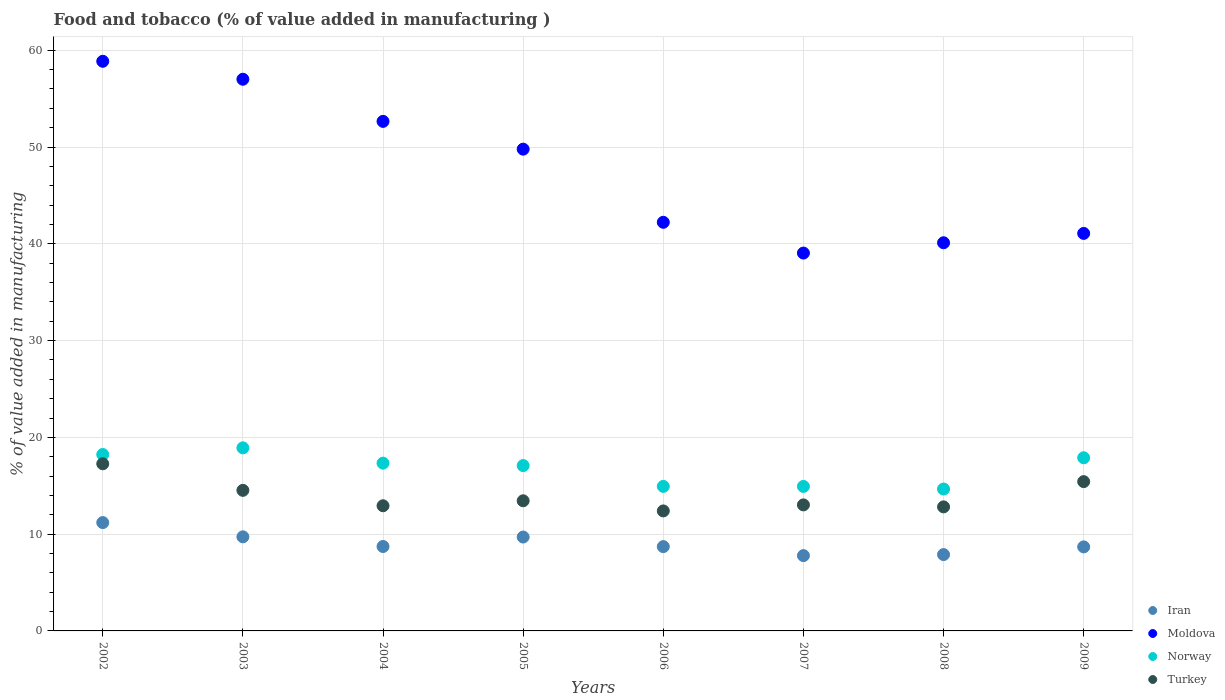How many different coloured dotlines are there?
Provide a short and direct response. 4. Is the number of dotlines equal to the number of legend labels?
Ensure brevity in your answer.  Yes. What is the value added in manufacturing food and tobacco in Iran in 2002?
Give a very brief answer. 11.19. Across all years, what is the maximum value added in manufacturing food and tobacco in Norway?
Your response must be concise. 18.92. Across all years, what is the minimum value added in manufacturing food and tobacco in Turkey?
Keep it short and to the point. 12.4. In which year was the value added in manufacturing food and tobacco in Moldova minimum?
Your answer should be compact. 2007. What is the total value added in manufacturing food and tobacco in Iran in the graph?
Offer a terse response. 72.4. What is the difference between the value added in manufacturing food and tobacco in Iran in 2006 and that in 2008?
Ensure brevity in your answer.  0.82. What is the difference between the value added in manufacturing food and tobacco in Iran in 2005 and the value added in manufacturing food and tobacco in Moldova in 2007?
Give a very brief answer. -29.34. What is the average value added in manufacturing food and tobacco in Norway per year?
Offer a very short reply. 16.75. In the year 2004, what is the difference between the value added in manufacturing food and tobacco in Turkey and value added in manufacturing food and tobacco in Norway?
Offer a very short reply. -4.4. What is the ratio of the value added in manufacturing food and tobacco in Turkey in 2006 to that in 2008?
Your answer should be very brief. 0.97. Is the difference between the value added in manufacturing food and tobacco in Turkey in 2007 and 2009 greater than the difference between the value added in manufacturing food and tobacco in Norway in 2007 and 2009?
Ensure brevity in your answer.  Yes. What is the difference between the highest and the second highest value added in manufacturing food and tobacco in Iran?
Give a very brief answer. 1.47. What is the difference between the highest and the lowest value added in manufacturing food and tobacco in Moldova?
Provide a succinct answer. 19.82. Is it the case that in every year, the sum of the value added in manufacturing food and tobacco in Norway and value added in manufacturing food and tobacco in Iran  is greater than the sum of value added in manufacturing food and tobacco in Moldova and value added in manufacturing food and tobacco in Turkey?
Ensure brevity in your answer.  No. Does the value added in manufacturing food and tobacco in Turkey monotonically increase over the years?
Ensure brevity in your answer.  No. Is the value added in manufacturing food and tobacco in Moldova strictly greater than the value added in manufacturing food and tobacco in Turkey over the years?
Offer a terse response. Yes. How many dotlines are there?
Provide a succinct answer. 4. How many years are there in the graph?
Your response must be concise. 8. Where does the legend appear in the graph?
Your response must be concise. Bottom right. How many legend labels are there?
Make the answer very short. 4. How are the legend labels stacked?
Give a very brief answer. Vertical. What is the title of the graph?
Make the answer very short. Food and tobacco (% of value added in manufacturing ). What is the label or title of the X-axis?
Your answer should be compact. Years. What is the label or title of the Y-axis?
Your answer should be very brief. % of value added in manufacturing. What is the % of value added in manufacturing of Iran in 2002?
Your answer should be very brief. 11.19. What is the % of value added in manufacturing in Moldova in 2002?
Offer a very short reply. 58.86. What is the % of value added in manufacturing of Norway in 2002?
Ensure brevity in your answer.  18.23. What is the % of value added in manufacturing of Turkey in 2002?
Provide a succinct answer. 17.27. What is the % of value added in manufacturing in Iran in 2003?
Provide a succinct answer. 9.72. What is the % of value added in manufacturing in Moldova in 2003?
Provide a short and direct response. 57. What is the % of value added in manufacturing in Norway in 2003?
Ensure brevity in your answer.  18.92. What is the % of value added in manufacturing of Turkey in 2003?
Your answer should be very brief. 14.52. What is the % of value added in manufacturing of Iran in 2004?
Offer a terse response. 8.72. What is the % of value added in manufacturing in Moldova in 2004?
Keep it short and to the point. 52.65. What is the % of value added in manufacturing of Norway in 2004?
Give a very brief answer. 17.34. What is the % of value added in manufacturing in Turkey in 2004?
Make the answer very short. 12.93. What is the % of value added in manufacturing of Iran in 2005?
Your response must be concise. 9.7. What is the % of value added in manufacturing of Moldova in 2005?
Keep it short and to the point. 49.78. What is the % of value added in manufacturing in Norway in 2005?
Keep it short and to the point. 17.08. What is the % of value added in manufacturing of Turkey in 2005?
Ensure brevity in your answer.  13.45. What is the % of value added in manufacturing in Iran in 2006?
Provide a succinct answer. 8.71. What is the % of value added in manufacturing in Moldova in 2006?
Your response must be concise. 42.22. What is the % of value added in manufacturing in Norway in 2006?
Your answer should be very brief. 14.93. What is the % of value added in manufacturing in Turkey in 2006?
Give a very brief answer. 12.4. What is the % of value added in manufacturing of Iran in 2007?
Offer a terse response. 7.78. What is the % of value added in manufacturing of Moldova in 2007?
Ensure brevity in your answer.  39.04. What is the % of value added in manufacturing in Norway in 2007?
Keep it short and to the point. 14.93. What is the % of value added in manufacturing of Turkey in 2007?
Ensure brevity in your answer.  13.02. What is the % of value added in manufacturing in Iran in 2008?
Offer a terse response. 7.89. What is the % of value added in manufacturing of Moldova in 2008?
Keep it short and to the point. 40.11. What is the % of value added in manufacturing in Norway in 2008?
Keep it short and to the point. 14.66. What is the % of value added in manufacturing in Turkey in 2008?
Your response must be concise. 12.82. What is the % of value added in manufacturing in Iran in 2009?
Give a very brief answer. 8.68. What is the % of value added in manufacturing in Moldova in 2009?
Ensure brevity in your answer.  41.07. What is the % of value added in manufacturing of Norway in 2009?
Provide a short and direct response. 17.89. What is the % of value added in manufacturing in Turkey in 2009?
Ensure brevity in your answer.  15.43. Across all years, what is the maximum % of value added in manufacturing in Iran?
Your answer should be compact. 11.19. Across all years, what is the maximum % of value added in manufacturing of Moldova?
Make the answer very short. 58.86. Across all years, what is the maximum % of value added in manufacturing of Norway?
Your response must be concise. 18.92. Across all years, what is the maximum % of value added in manufacturing of Turkey?
Offer a very short reply. 17.27. Across all years, what is the minimum % of value added in manufacturing in Iran?
Provide a succinct answer. 7.78. Across all years, what is the minimum % of value added in manufacturing in Moldova?
Give a very brief answer. 39.04. Across all years, what is the minimum % of value added in manufacturing in Norway?
Keep it short and to the point. 14.66. Across all years, what is the minimum % of value added in manufacturing of Turkey?
Your answer should be very brief. 12.4. What is the total % of value added in manufacturing in Iran in the graph?
Ensure brevity in your answer.  72.4. What is the total % of value added in manufacturing of Moldova in the graph?
Give a very brief answer. 380.73. What is the total % of value added in manufacturing of Norway in the graph?
Provide a succinct answer. 133.98. What is the total % of value added in manufacturing in Turkey in the graph?
Keep it short and to the point. 111.84. What is the difference between the % of value added in manufacturing of Iran in 2002 and that in 2003?
Offer a terse response. 1.47. What is the difference between the % of value added in manufacturing of Moldova in 2002 and that in 2003?
Offer a terse response. 1.86. What is the difference between the % of value added in manufacturing of Norway in 2002 and that in 2003?
Ensure brevity in your answer.  -0.69. What is the difference between the % of value added in manufacturing of Turkey in 2002 and that in 2003?
Offer a very short reply. 2.75. What is the difference between the % of value added in manufacturing of Iran in 2002 and that in 2004?
Ensure brevity in your answer.  2.47. What is the difference between the % of value added in manufacturing in Moldova in 2002 and that in 2004?
Your answer should be very brief. 6.21. What is the difference between the % of value added in manufacturing of Norway in 2002 and that in 2004?
Offer a terse response. 0.89. What is the difference between the % of value added in manufacturing of Turkey in 2002 and that in 2004?
Give a very brief answer. 4.34. What is the difference between the % of value added in manufacturing of Iran in 2002 and that in 2005?
Give a very brief answer. 1.49. What is the difference between the % of value added in manufacturing of Moldova in 2002 and that in 2005?
Make the answer very short. 9.08. What is the difference between the % of value added in manufacturing of Norway in 2002 and that in 2005?
Provide a short and direct response. 1.14. What is the difference between the % of value added in manufacturing of Turkey in 2002 and that in 2005?
Give a very brief answer. 3.82. What is the difference between the % of value added in manufacturing of Iran in 2002 and that in 2006?
Offer a terse response. 2.48. What is the difference between the % of value added in manufacturing of Moldova in 2002 and that in 2006?
Keep it short and to the point. 16.64. What is the difference between the % of value added in manufacturing in Norway in 2002 and that in 2006?
Your response must be concise. 3.29. What is the difference between the % of value added in manufacturing of Turkey in 2002 and that in 2006?
Offer a terse response. 4.87. What is the difference between the % of value added in manufacturing of Iran in 2002 and that in 2007?
Give a very brief answer. 3.41. What is the difference between the % of value added in manufacturing of Moldova in 2002 and that in 2007?
Ensure brevity in your answer.  19.82. What is the difference between the % of value added in manufacturing of Norway in 2002 and that in 2007?
Your response must be concise. 3.3. What is the difference between the % of value added in manufacturing in Turkey in 2002 and that in 2007?
Ensure brevity in your answer.  4.25. What is the difference between the % of value added in manufacturing of Iran in 2002 and that in 2008?
Provide a short and direct response. 3.31. What is the difference between the % of value added in manufacturing of Moldova in 2002 and that in 2008?
Keep it short and to the point. 18.75. What is the difference between the % of value added in manufacturing of Norway in 2002 and that in 2008?
Your answer should be very brief. 3.56. What is the difference between the % of value added in manufacturing of Turkey in 2002 and that in 2008?
Offer a very short reply. 4.45. What is the difference between the % of value added in manufacturing in Iran in 2002 and that in 2009?
Offer a very short reply. 2.51. What is the difference between the % of value added in manufacturing of Moldova in 2002 and that in 2009?
Ensure brevity in your answer.  17.79. What is the difference between the % of value added in manufacturing in Norway in 2002 and that in 2009?
Keep it short and to the point. 0.34. What is the difference between the % of value added in manufacturing in Turkey in 2002 and that in 2009?
Keep it short and to the point. 1.84. What is the difference between the % of value added in manufacturing in Moldova in 2003 and that in 2004?
Offer a very short reply. 4.35. What is the difference between the % of value added in manufacturing in Norway in 2003 and that in 2004?
Offer a terse response. 1.58. What is the difference between the % of value added in manufacturing of Turkey in 2003 and that in 2004?
Keep it short and to the point. 1.59. What is the difference between the % of value added in manufacturing of Iran in 2003 and that in 2005?
Provide a short and direct response. 0.02. What is the difference between the % of value added in manufacturing of Moldova in 2003 and that in 2005?
Give a very brief answer. 7.22. What is the difference between the % of value added in manufacturing in Norway in 2003 and that in 2005?
Ensure brevity in your answer.  1.83. What is the difference between the % of value added in manufacturing in Turkey in 2003 and that in 2005?
Provide a succinct answer. 1.08. What is the difference between the % of value added in manufacturing in Iran in 2003 and that in 2006?
Your answer should be compact. 1.01. What is the difference between the % of value added in manufacturing of Moldova in 2003 and that in 2006?
Your response must be concise. 14.78. What is the difference between the % of value added in manufacturing in Norway in 2003 and that in 2006?
Your answer should be very brief. 3.98. What is the difference between the % of value added in manufacturing in Turkey in 2003 and that in 2006?
Your answer should be very brief. 2.13. What is the difference between the % of value added in manufacturing of Iran in 2003 and that in 2007?
Offer a very short reply. 1.94. What is the difference between the % of value added in manufacturing of Moldova in 2003 and that in 2007?
Offer a terse response. 17.96. What is the difference between the % of value added in manufacturing in Norway in 2003 and that in 2007?
Keep it short and to the point. 3.99. What is the difference between the % of value added in manufacturing in Turkey in 2003 and that in 2007?
Your response must be concise. 1.5. What is the difference between the % of value added in manufacturing in Iran in 2003 and that in 2008?
Your answer should be very brief. 1.84. What is the difference between the % of value added in manufacturing of Moldova in 2003 and that in 2008?
Give a very brief answer. 16.9. What is the difference between the % of value added in manufacturing of Norway in 2003 and that in 2008?
Give a very brief answer. 4.25. What is the difference between the % of value added in manufacturing of Turkey in 2003 and that in 2008?
Your answer should be very brief. 1.71. What is the difference between the % of value added in manufacturing of Iran in 2003 and that in 2009?
Provide a succinct answer. 1.04. What is the difference between the % of value added in manufacturing in Moldova in 2003 and that in 2009?
Give a very brief answer. 15.93. What is the difference between the % of value added in manufacturing in Norway in 2003 and that in 2009?
Offer a very short reply. 1.03. What is the difference between the % of value added in manufacturing of Turkey in 2003 and that in 2009?
Your answer should be compact. -0.9. What is the difference between the % of value added in manufacturing in Iran in 2004 and that in 2005?
Offer a very short reply. -0.98. What is the difference between the % of value added in manufacturing of Moldova in 2004 and that in 2005?
Provide a short and direct response. 2.87. What is the difference between the % of value added in manufacturing of Norway in 2004 and that in 2005?
Give a very brief answer. 0.25. What is the difference between the % of value added in manufacturing in Turkey in 2004 and that in 2005?
Offer a very short reply. -0.51. What is the difference between the % of value added in manufacturing of Iran in 2004 and that in 2006?
Offer a terse response. 0.01. What is the difference between the % of value added in manufacturing of Moldova in 2004 and that in 2006?
Provide a short and direct response. 10.43. What is the difference between the % of value added in manufacturing in Norway in 2004 and that in 2006?
Keep it short and to the point. 2.4. What is the difference between the % of value added in manufacturing in Turkey in 2004 and that in 2006?
Give a very brief answer. 0.53. What is the difference between the % of value added in manufacturing of Iran in 2004 and that in 2007?
Your answer should be compact. 0.94. What is the difference between the % of value added in manufacturing of Moldova in 2004 and that in 2007?
Make the answer very short. 13.61. What is the difference between the % of value added in manufacturing in Norway in 2004 and that in 2007?
Ensure brevity in your answer.  2.41. What is the difference between the % of value added in manufacturing of Turkey in 2004 and that in 2007?
Give a very brief answer. -0.09. What is the difference between the % of value added in manufacturing of Iran in 2004 and that in 2008?
Offer a terse response. 0.84. What is the difference between the % of value added in manufacturing in Moldova in 2004 and that in 2008?
Keep it short and to the point. 12.54. What is the difference between the % of value added in manufacturing in Norway in 2004 and that in 2008?
Provide a succinct answer. 2.67. What is the difference between the % of value added in manufacturing of Turkey in 2004 and that in 2008?
Offer a very short reply. 0.12. What is the difference between the % of value added in manufacturing of Iran in 2004 and that in 2009?
Make the answer very short. 0.04. What is the difference between the % of value added in manufacturing in Moldova in 2004 and that in 2009?
Keep it short and to the point. 11.58. What is the difference between the % of value added in manufacturing in Norway in 2004 and that in 2009?
Ensure brevity in your answer.  -0.56. What is the difference between the % of value added in manufacturing in Turkey in 2004 and that in 2009?
Your answer should be compact. -2.49. What is the difference between the % of value added in manufacturing of Iran in 2005 and that in 2006?
Provide a short and direct response. 0.99. What is the difference between the % of value added in manufacturing of Moldova in 2005 and that in 2006?
Your response must be concise. 7.56. What is the difference between the % of value added in manufacturing in Norway in 2005 and that in 2006?
Give a very brief answer. 2.15. What is the difference between the % of value added in manufacturing in Turkey in 2005 and that in 2006?
Your answer should be very brief. 1.05. What is the difference between the % of value added in manufacturing in Iran in 2005 and that in 2007?
Your answer should be very brief. 1.92. What is the difference between the % of value added in manufacturing of Moldova in 2005 and that in 2007?
Your answer should be very brief. 10.74. What is the difference between the % of value added in manufacturing in Norway in 2005 and that in 2007?
Offer a terse response. 2.16. What is the difference between the % of value added in manufacturing of Turkey in 2005 and that in 2007?
Offer a terse response. 0.42. What is the difference between the % of value added in manufacturing in Iran in 2005 and that in 2008?
Offer a terse response. 1.81. What is the difference between the % of value added in manufacturing in Moldova in 2005 and that in 2008?
Your response must be concise. 9.67. What is the difference between the % of value added in manufacturing in Norway in 2005 and that in 2008?
Keep it short and to the point. 2.42. What is the difference between the % of value added in manufacturing in Turkey in 2005 and that in 2008?
Offer a very short reply. 0.63. What is the difference between the % of value added in manufacturing of Iran in 2005 and that in 2009?
Keep it short and to the point. 1.02. What is the difference between the % of value added in manufacturing of Moldova in 2005 and that in 2009?
Your answer should be very brief. 8.71. What is the difference between the % of value added in manufacturing of Norway in 2005 and that in 2009?
Offer a very short reply. -0.81. What is the difference between the % of value added in manufacturing of Turkey in 2005 and that in 2009?
Offer a very short reply. -1.98. What is the difference between the % of value added in manufacturing of Iran in 2006 and that in 2007?
Offer a terse response. 0.93. What is the difference between the % of value added in manufacturing in Moldova in 2006 and that in 2007?
Your response must be concise. 3.18. What is the difference between the % of value added in manufacturing in Norway in 2006 and that in 2007?
Ensure brevity in your answer.  0.01. What is the difference between the % of value added in manufacturing in Turkey in 2006 and that in 2007?
Ensure brevity in your answer.  -0.62. What is the difference between the % of value added in manufacturing in Iran in 2006 and that in 2008?
Provide a short and direct response. 0.82. What is the difference between the % of value added in manufacturing in Moldova in 2006 and that in 2008?
Ensure brevity in your answer.  2.11. What is the difference between the % of value added in manufacturing of Norway in 2006 and that in 2008?
Your answer should be very brief. 0.27. What is the difference between the % of value added in manufacturing of Turkey in 2006 and that in 2008?
Make the answer very short. -0.42. What is the difference between the % of value added in manufacturing in Iran in 2006 and that in 2009?
Provide a short and direct response. 0.03. What is the difference between the % of value added in manufacturing of Moldova in 2006 and that in 2009?
Give a very brief answer. 1.15. What is the difference between the % of value added in manufacturing of Norway in 2006 and that in 2009?
Offer a terse response. -2.96. What is the difference between the % of value added in manufacturing in Turkey in 2006 and that in 2009?
Your answer should be very brief. -3.03. What is the difference between the % of value added in manufacturing of Iran in 2007 and that in 2008?
Keep it short and to the point. -0.11. What is the difference between the % of value added in manufacturing of Moldova in 2007 and that in 2008?
Offer a very short reply. -1.06. What is the difference between the % of value added in manufacturing in Norway in 2007 and that in 2008?
Offer a terse response. 0.27. What is the difference between the % of value added in manufacturing in Turkey in 2007 and that in 2008?
Your answer should be very brief. 0.21. What is the difference between the % of value added in manufacturing of Iran in 2007 and that in 2009?
Offer a very short reply. -0.9. What is the difference between the % of value added in manufacturing of Moldova in 2007 and that in 2009?
Your response must be concise. -2.03. What is the difference between the % of value added in manufacturing in Norway in 2007 and that in 2009?
Offer a very short reply. -2.96. What is the difference between the % of value added in manufacturing in Turkey in 2007 and that in 2009?
Your response must be concise. -2.4. What is the difference between the % of value added in manufacturing of Iran in 2008 and that in 2009?
Make the answer very short. -0.8. What is the difference between the % of value added in manufacturing in Moldova in 2008 and that in 2009?
Your answer should be very brief. -0.97. What is the difference between the % of value added in manufacturing in Norway in 2008 and that in 2009?
Offer a terse response. -3.23. What is the difference between the % of value added in manufacturing of Turkey in 2008 and that in 2009?
Offer a terse response. -2.61. What is the difference between the % of value added in manufacturing in Iran in 2002 and the % of value added in manufacturing in Moldova in 2003?
Give a very brief answer. -45.81. What is the difference between the % of value added in manufacturing in Iran in 2002 and the % of value added in manufacturing in Norway in 2003?
Ensure brevity in your answer.  -7.72. What is the difference between the % of value added in manufacturing in Iran in 2002 and the % of value added in manufacturing in Turkey in 2003?
Your answer should be compact. -3.33. What is the difference between the % of value added in manufacturing of Moldova in 2002 and the % of value added in manufacturing of Norway in 2003?
Make the answer very short. 39.94. What is the difference between the % of value added in manufacturing of Moldova in 2002 and the % of value added in manufacturing of Turkey in 2003?
Offer a very short reply. 44.33. What is the difference between the % of value added in manufacturing in Norway in 2002 and the % of value added in manufacturing in Turkey in 2003?
Provide a succinct answer. 3.7. What is the difference between the % of value added in manufacturing of Iran in 2002 and the % of value added in manufacturing of Moldova in 2004?
Give a very brief answer. -41.46. What is the difference between the % of value added in manufacturing in Iran in 2002 and the % of value added in manufacturing in Norway in 2004?
Keep it short and to the point. -6.14. What is the difference between the % of value added in manufacturing of Iran in 2002 and the % of value added in manufacturing of Turkey in 2004?
Keep it short and to the point. -1.74. What is the difference between the % of value added in manufacturing in Moldova in 2002 and the % of value added in manufacturing in Norway in 2004?
Your response must be concise. 41.52. What is the difference between the % of value added in manufacturing in Moldova in 2002 and the % of value added in manufacturing in Turkey in 2004?
Offer a very short reply. 45.93. What is the difference between the % of value added in manufacturing in Norway in 2002 and the % of value added in manufacturing in Turkey in 2004?
Give a very brief answer. 5.3. What is the difference between the % of value added in manufacturing in Iran in 2002 and the % of value added in manufacturing in Moldova in 2005?
Make the answer very short. -38.59. What is the difference between the % of value added in manufacturing of Iran in 2002 and the % of value added in manufacturing of Norway in 2005?
Offer a very short reply. -5.89. What is the difference between the % of value added in manufacturing of Iran in 2002 and the % of value added in manufacturing of Turkey in 2005?
Give a very brief answer. -2.25. What is the difference between the % of value added in manufacturing of Moldova in 2002 and the % of value added in manufacturing of Norway in 2005?
Your answer should be compact. 41.77. What is the difference between the % of value added in manufacturing in Moldova in 2002 and the % of value added in manufacturing in Turkey in 2005?
Provide a short and direct response. 45.41. What is the difference between the % of value added in manufacturing of Norway in 2002 and the % of value added in manufacturing of Turkey in 2005?
Your response must be concise. 4.78. What is the difference between the % of value added in manufacturing in Iran in 2002 and the % of value added in manufacturing in Moldova in 2006?
Offer a very short reply. -31.03. What is the difference between the % of value added in manufacturing in Iran in 2002 and the % of value added in manufacturing in Norway in 2006?
Offer a very short reply. -3.74. What is the difference between the % of value added in manufacturing of Iran in 2002 and the % of value added in manufacturing of Turkey in 2006?
Ensure brevity in your answer.  -1.2. What is the difference between the % of value added in manufacturing in Moldova in 2002 and the % of value added in manufacturing in Norway in 2006?
Your response must be concise. 43.92. What is the difference between the % of value added in manufacturing of Moldova in 2002 and the % of value added in manufacturing of Turkey in 2006?
Keep it short and to the point. 46.46. What is the difference between the % of value added in manufacturing in Norway in 2002 and the % of value added in manufacturing in Turkey in 2006?
Your answer should be very brief. 5.83. What is the difference between the % of value added in manufacturing in Iran in 2002 and the % of value added in manufacturing in Moldova in 2007?
Make the answer very short. -27.85. What is the difference between the % of value added in manufacturing of Iran in 2002 and the % of value added in manufacturing of Norway in 2007?
Your response must be concise. -3.74. What is the difference between the % of value added in manufacturing in Iran in 2002 and the % of value added in manufacturing in Turkey in 2007?
Provide a short and direct response. -1.83. What is the difference between the % of value added in manufacturing in Moldova in 2002 and the % of value added in manufacturing in Norway in 2007?
Offer a very short reply. 43.93. What is the difference between the % of value added in manufacturing of Moldova in 2002 and the % of value added in manufacturing of Turkey in 2007?
Give a very brief answer. 45.84. What is the difference between the % of value added in manufacturing in Norway in 2002 and the % of value added in manufacturing in Turkey in 2007?
Offer a terse response. 5.21. What is the difference between the % of value added in manufacturing in Iran in 2002 and the % of value added in manufacturing in Moldova in 2008?
Your answer should be very brief. -28.91. What is the difference between the % of value added in manufacturing in Iran in 2002 and the % of value added in manufacturing in Norway in 2008?
Your answer should be compact. -3.47. What is the difference between the % of value added in manufacturing of Iran in 2002 and the % of value added in manufacturing of Turkey in 2008?
Offer a terse response. -1.62. What is the difference between the % of value added in manufacturing of Moldova in 2002 and the % of value added in manufacturing of Norway in 2008?
Give a very brief answer. 44.2. What is the difference between the % of value added in manufacturing in Moldova in 2002 and the % of value added in manufacturing in Turkey in 2008?
Provide a succinct answer. 46.04. What is the difference between the % of value added in manufacturing of Norway in 2002 and the % of value added in manufacturing of Turkey in 2008?
Provide a succinct answer. 5.41. What is the difference between the % of value added in manufacturing in Iran in 2002 and the % of value added in manufacturing in Moldova in 2009?
Your response must be concise. -29.88. What is the difference between the % of value added in manufacturing in Iran in 2002 and the % of value added in manufacturing in Norway in 2009?
Your response must be concise. -6.7. What is the difference between the % of value added in manufacturing of Iran in 2002 and the % of value added in manufacturing of Turkey in 2009?
Provide a succinct answer. -4.23. What is the difference between the % of value added in manufacturing of Moldova in 2002 and the % of value added in manufacturing of Norway in 2009?
Offer a very short reply. 40.97. What is the difference between the % of value added in manufacturing in Moldova in 2002 and the % of value added in manufacturing in Turkey in 2009?
Ensure brevity in your answer.  43.43. What is the difference between the % of value added in manufacturing of Norway in 2002 and the % of value added in manufacturing of Turkey in 2009?
Your response must be concise. 2.8. What is the difference between the % of value added in manufacturing of Iran in 2003 and the % of value added in manufacturing of Moldova in 2004?
Offer a very short reply. -42.93. What is the difference between the % of value added in manufacturing in Iran in 2003 and the % of value added in manufacturing in Norway in 2004?
Your response must be concise. -7.61. What is the difference between the % of value added in manufacturing of Iran in 2003 and the % of value added in manufacturing of Turkey in 2004?
Provide a succinct answer. -3.21. What is the difference between the % of value added in manufacturing in Moldova in 2003 and the % of value added in manufacturing in Norway in 2004?
Provide a succinct answer. 39.67. What is the difference between the % of value added in manufacturing of Moldova in 2003 and the % of value added in manufacturing of Turkey in 2004?
Your answer should be very brief. 44.07. What is the difference between the % of value added in manufacturing of Norway in 2003 and the % of value added in manufacturing of Turkey in 2004?
Your response must be concise. 5.99. What is the difference between the % of value added in manufacturing in Iran in 2003 and the % of value added in manufacturing in Moldova in 2005?
Provide a short and direct response. -40.06. What is the difference between the % of value added in manufacturing in Iran in 2003 and the % of value added in manufacturing in Norway in 2005?
Your answer should be compact. -7.36. What is the difference between the % of value added in manufacturing of Iran in 2003 and the % of value added in manufacturing of Turkey in 2005?
Provide a succinct answer. -3.72. What is the difference between the % of value added in manufacturing in Moldova in 2003 and the % of value added in manufacturing in Norway in 2005?
Keep it short and to the point. 39.92. What is the difference between the % of value added in manufacturing in Moldova in 2003 and the % of value added in manufacturing in Turkey in 2005?
Provide a short and direct response. 43.56. What is the difference between the % of value added in manufacturing of Norway in 2003 and the % of value added in manufacturing of Turkey in 2005?
Offer a terse response. 5.47. What is the difference between the % of value added in manufacturing of Iran in 2003 and the % of value added in manufacturing of Moldova in 2006?
Your answer should be very brief. -32.5. What is the difference between the % of value added in manufacturing in Iran in 2003 and the % of value added in manufacturing in Norway in 2006?
Provide a short and direct response. -5.21. What is the difference between the % of value added in manufacturing of Iran in 2003 and the % of value added in manufacturing of Turkey in 2006?
Offer a very short reply. -2.68. What is the difference between the % of value added in manufacturing of Moldova in 2003 and the % of value added in manufacturing of Norway in 2006?
Make the answer very short. 42.07. What is the difference between the % of value added in manufacturing of Moldova in 2003 and the % of value added in manufacturing of Turkey in 2006?
Give a very brief answer. 44.6. What is the difference between the % of value added in manufacturing in Norway in 2003 and the % of value added in manufacturing in Turkey in 2006?
Keep it short and to the point. 6.52. What is the difference between the % of value added in manufacturing in Iran in 2003 and the % of value added in manufacturing in Moldova in 2007?
Provide a succinct answer. -29.32. What is the difference between the % of value added in manufacturing of Iran in 2003 and the % of value added in manufacturing of Norway in 2007?
Your answer should be very brief. -5.21. What is the difference between the % of value added in manufacturing of Iran in 2003 and the % of value added in manufacturing of Turkey in 2007?
Keep it short and to the point. -3.3. What is the difference between the % of value added in manufacturing in Moldova in 2003 and the % of value added in manufacturing in Norway in 2007?
Ensure brevity in your answer.  42.07. What is the difference between the % of value added in manufacturing of Moldova in 2003 and the % of value added in manufacturing of Turkey in 2007?
Provide a short and direct response. 43.98. What is the difference between the % of value added in manufacturing in Norway in 2003 and the % of value added in manufacturing in Turkey in 2007?
Your answer should be very brief. 5.89. What is the difference between the % of value added in manufacturing in Iran in 2003 and the % of value added in manufacturing in Moldova in 2008?
Give a very brief answer. -30.38. What is the difference between the % of value added in manufacturing in Iran in 2003 and the % of value added in manufacturing in Norway in 2008?
Make the answer very short. -4.94. What is the difference between the % of value added in manufacturing of Iran in 2003 and the % of value added in manufacturing of Turkey in 2008?
Offer a very short reply. -3.09. What is the difference between the % of value added in manufacturing in Moldova in 2003 and the % of value added in manufacturing in Norway in 2008?
Your answer should be very brief. 42.34. What is the difference between the % of value added in manufacturing of Moldova in 2003 and the % of value added in manufacturing of Turkey in 2008?
Keep it short and to the point. 44.19. What is the difference between the % of value added in manufacturing of Norway in 2003 and the % of value added in manufacturing of Turkey in 2008?
Your answer should be compact. 6.1. What is the difference between the % of value added in manufacturing in Iran in 2003 and the % of value added in manufacturing in Moldova in 2009?
Provide a succinct answer. -31.35. What is the difference between the % of value added in manufacturing of Iran in 2003 and the % of value added in manufacturing of Norway in 2009?
Your answer should be very brief. -8.17. What is the difference between the % of value added in manufacturing of Iran in 2003 and the % of value added in manufacturing of Turkey in 2009?
Provide a short and direct response. -5.7. What is the difference between the % of value added in manufacturing in Moldova in 2003 and the % of value added in manufacturing in Norway in 2009?
Ensure brevity in your answer.  39.11. What is the difference between the % of value added in manufacturing in Moldova in 2003 and the % of value added in manufacturing in Turkey in 2009?
Ensure brevity in your answer.  41.58. What is the difference between the % of value added in manufacturing in Norway in 2003 and the % of value added in manufacturing in Turkey in 2009?
Keep it short and to the point. 3.49. What is the difference between the % of value added in manufacturing of Iran in 2004 and the % of value added in manufacturing of Moldova in 2005?
Offer a very short reply. -41.06. What is the difference between the % of value added in manufacturing in Iran in 2004 and the % of value added in manufacturing in Norway in 2005?
Your answer should be very brief. -8.36. What is the difference between the % of value added in manufacturing of Iran in 2004 and the % of value added in manufacturing of Turkey in 2005?
Your answer should be compact. -4.72. What is the difference between the % of value added in manufacturing of Moldova in 2004 and the % of value added in manufacturing of Norway in 2005?
Provide a short and direct response. 35.56. What is the difference between the % of value added in manufacturing of Moldova in 2004 and the % of value added in manufacturing of Turkey in 2005?
Offer a terse response. 39.2. What is the difference between the % of value added in manufacturing of Norway in 2004 and the % of value added in manufacturing of Turkey in 2005?
Keep it short and to the point. 3.89. What is the difference between the % of value added in manufacturing of Iran in 2004 and the % of value added in manufacturing of Moldova in 2006?
Keep it short and to the point. -33.5. What is the difference between the % of value added in manufacturing of Iran in 2004 and the % of value added in manufacturing of Norway in 2006?
Give a very brief answer. -6.21. What is the difference between the % of value added in manufacturing in Iran in 2004 and the % of value added in manufacturing in Turkey in 2006?
Keep it short and to the point. -3.68. What is the difference between the % of value added in manufacturing in Moldova in 2004 and the % of value added in manufacturing in Norway in 2006?
Ensure brevity in your answer.  37.72. What is the difference between the % of value added in manufacturing of Moldova in 2004 and the % of value added in manufacturing of Turkey in 2006?
Your answer should be compact. 40.25. What is the difference between the % of value added in manufacturing in Norway in 2004 and the % of value added in manufacturing in Turkey in 2006?
Provide a succinct answer. 4.94. What is the difference between the % of value added in manufacturing in Iran in 2004 and the % of value added in manufacturing in Moldova in 2007?
Your answer should be very brief. -30.32. What is the difference between the % of value added in manufacturing in Iran in 2004 and the % of value added in manufacturing in Norway in 2007?
Your answer should be compact. -6.21. What is the difference between the % of value added in manufacturing in Iran in 2004 and the % of value added in manufacturing in Turkey in 2007?
Your response must be concise. -4.3. What is the difference between the % of value added in manufacturing of Moldova in 2004 and the % of value added in manufacturing of Norway in 2007?
Provide a short and direct response. 37.72. What is the difference between the % of value added in manufacturing of Moldova in 2004 and the % of value added in manufacturing of Turkey in 2007?
Make the answer very short. 39.63. What is the difference between the % of value added in manufacturing of Norway in 2004 and the % of value added in manufacturing of Turkey in 2007?
Provide a succinct answer. 4.31. What is the difference between the % of value added in manufacturing of Iran in 2004 and the % of value added in manufacturing of Moldova in 2008?
Ensure brevity in your answer.  -31.38. What is the difference between the % of value added in manufacturing in Iran in 2004 and the % of value added in manufacturing in Norway in 2008?
Give a very brief answer. -5.94. What is the difference between the % of value added in manufacturing in Iran in 2004 and the % of value added in manufacturing in Turkey in 2008?
Offer a terse response. -4.09. What is the difference between the % of value added in manufacturing in Moldova in 2004 and the % of value added in manufacturing in Norway in 2008?
Your answer should be very brief. 37.99. What is the difference between the % of value added in manufacturing in Moldova in 2004 and the % of value added in manufacturing in Turkey in 2008?
Offer a terse response. 39.83. What is the difference between the % of value added in manufacturing of Norway in 2004 and the % of value added in manufacturing of Turkey in 2008?
Provide a succinct answer. 4.52. What is the difference between the % of value added in manufacturing of Iran in 2004 and the % of value added in manufacturing of Moldova in 2009?
Your answer should be compact. -32.35. What is the difference between the % of value added in manufacturing of Iran in 2004 and the % of value added in manufacturing of Norway in 2009?
Make the answer very short. -9.17. What is the difference between the % of value added in manufacturing in Iran in 2004 and the % of value added in manufacturing in Turkey in 2009?
Your response must be concise. -6.7. What is the difference between the % of value added in manufacturing of Moldova in 2004 and the % of value added in manufacturing of Norway in 2009?
Make the answer very short. 34.76. What is the difference between the % of value added in manufacturing in Moldova in 2004 and the % of value added in manufacturing in Turkey in 2009?
Your response must be concise. 37.22. What is the difference between the % of value added in manufacturing in Norway in 2004 and the % of value added in manufacturing in Turkey in 2009?
Your response must be concise. 1.91. What is the difference between the % of value added in manufacturing of Iran in 2005 and the % of value added in manufacturing of Moldova in 2006?
Your answer should be very brief. -32.52. What is the difference between the % of value added in manufacturing in Iran in 2005 and the % of value added in manufacturing in Norway in 2006?
Your answer should be very brief. -5.23. What is the difference between the % of value added in manufacturing in Iran in 2005 and the % of value added in manufacturing in Turkey in 2006?
Give a very brief answer. -2.7. What is the difference between the % of value added in manufacturing of Moldova in 2005 and the % of value added in manufacturing of Norway in 2006?
Provide a succinct answer. 34.84. What is the difference between the % of value added in manufacturing of Moldova in 2005 and the % of value added in manufacturing of Turkey in 2006?
Your answer should be very brief. 37.38. What is the difference between the % of value added in manufacturing in Norway in 2005 and the % of value added in manufacturing in Turkey in 2006?
Ensure brevity in your answer.  4.69. What is the difference between the % of value added in manufacturing of Iran in 2005 and the % of value added in manufacturing of Moldova in 2007?
Provide a short and direct response. -29.34. What is the difference between the % of value added in manufacturing of Iran in 2005 and the % of value added in manufacturing of Norway in 2007?
Keep it short and to the point. -5.23. What is the difference between the % of value added in manufacturing of Iran in 2005 and the % of value added in manufacturing of Turkey in 2007?
Keep it short and to the point. -3.32. What is the difference between the % of value added in manufacturing in Moldova in 2005 and the % of value added in manufacturing in Norway in 2007?
Give a very brief answer. 34.85. What is the difference between the % of value added in manufacturing of Moldova in 2005 and the % of value added in manufacturing of Turkey in 2007?
Offer a terse response. 36.76. What is the difference between the % of value added in manufacturing in Norway in 2005 and the % of value added in manufacturing in Turkey in 2007?
Your answer should be compact. 4.06. What is the difference between the % of value added in manufacturing of Iran in 2005 and the % of value added in manufacturing of Moldova in 2008?
Ensure brevity in your answer.  -30.41. What is the difference between the % of value added in manufacturing of Iran in 2005 and the % of value added in manufacturing of Norway in 2008?
Your answer should be very brief. -4.96. What is the difference between the % of value added in manufacturing of Iran in 2005 and the % of value added in manufacturing of Turkey in 2008?
Offer a very short reply. -3.12. What is the difference between the % of value added in manufacturing of Moldova in 2005 and the % of value added in manufacturing of Norway in 2008?
Your answer should be very brief. 35.12. What is the difference between the % of value added in manufacturing in Moldova in 2005 and the % of value added in manufacturing in Turkey in 2008?
Your answer should be very brief. 36.96. What is the difference between the % of value added in manufacturing of Norway in 2005 and the % of value added in manufacturing of Turkey in 2008?
Keep it short and to the point. 4.27. What is the difference between the % of value added in manufacturing of Iran in 2005 and the % of value added in manufacturing of Moldova in 2009?
Make the answer very short. -31.37. What is the difference between the % of value added in manufacturing of Iran in 2005 and the % of value added in manufacturing of Norway in 2009?
Keep it short and to the point. -8.19. What is the difference between the % of value added in manufacturing in Iran in 2005 and the % of value added in manufacturing in Turkey in 2009?
Keep it short and to the point. -5.73. What is the difference between the % of value added in manufacturing of Moldova in 2005 and the % of value added in manufacturing of Norway in 2009?
Keep it short and to the point. 31.89. What is the difference between the % of value added in manufacturing of Moldova in 2005 and the % of value added in manufacturing of Turkey in 2009?
Your answer should be compact. 34.35. What is the difference between the % of value added in manufacturing in Norway in 2005 and the % of value added in manufacturing in Turkey in 2009?
Your response must be concise. 1.66. What is the difference between the % of value added in manufacturing in Iran in 2006 and the % of value added in manufacturing in Moldova in 2007?
Make the answer very short. -30.33. What is the difference between the % of value added in manufacturing in Iran in 2006 and the % of value added in manufacturing in Norway in 2007?
Keep it short and to the point. -6.22. What is the difference between the % of value added in manufacturing in Iran in 2006 and the % of value added in manufacturing in Turkey in 2007?
Your response must be concise. -4.31. What is the difference between the % of value added in manufacturing of Moldova in 2006 and the % of value added in manufacturing of Norway in 2007?
Provide a short and direct response. 27.29. What is the difference between the % of value added in manufacturing of Moldova in 2006 and the % of value added in manufacturing of Turkey in 2007?
Provide a short and direct response. 29.2. What is the difference between the % of value added in manufacturing in Norway in 2006 and the % of value added in manufacturing in Turkey in 2007?
Your response must be concise. 1.91. What is the difference between the % of value added in manufacturing of Iran in 2006 and the % of value added in manufacturing of Moldova in 2008?
Your answer should be compact. -31.4. What is the difference between the % of value added in manufacturing in Iran in 2006 and the % of value added in manufacturing in Norway in 2008?
Your answer should be very brief. -5.95. What is the difference between the % of value added in manufacturing of Iran in 2006 and the % of value added in manufacturing of Turkey in 2008?
Offer a terse response. -4.11. What is the difference between the % of value added in manufacturing in Moldova in 2006 and the % of value added in manufacturing in Norway in 2008?
Your answer should be very brief. 27.56. What is the difference between the % of value added in manufacturing of Moldova in 2006 and the % of value added in manufacturing of Turkey in 2008?
Your answer should be very brief. 29.41. What is the difference between the % of value added in manufacturing of Norway in 2006 and the % of value added in manufacturing of Turkey in 2008?
Provide a succinct answer. 2.12. What is the difference between the % of value added in manufacturing in Iran in 2006 and the % of value added in manufacturing in Moldova in 2009?
Keep it short and to the point. -32.36. What is the difference between the % of value added in manufacturing in Iran in 2006 and the % of value added in manufacturing in Norway in 2009?
Make the answer very short. -9.18. What is the difference between the % of value added in manufacturing of Iran in 2006 and the % of value added in manufacturing of Turkey in 2009?
Give a very brief answer. -6.72. What is the difference between the % of value added in manufacturing of Moldova in 2006 and the % of value added in manufacturing of Norway in 2009?
Provide a succinct answer. 24.33. What is the difference between the % of value added in manufacturing of Moldova in 2006 and the % of value added in manufacturing of Turkey in 2009?
Ensure brevity in your answer.  26.8. What is the difference between the % of value added in manufacturing of Norway in 2006 and the % of value added in manufacturing of Turkey in 2009?
Offer a terse response. -0.49. What is the difference between the % of value added in manufacturing of Iran in 2007 and the % of value added in manufacturing of Moldova in 2008?
Ensure brevity in your answer.  -32.33. What is the difference between the % of value added in manufacturing of Iran in 2007 and the % of value added in manufacturing of Norway in 2008?
Give a very brief answer. -6.88. What is the difference between the % of value added in manufacturing of Iran in 2007 and the % of value added in manufacturing of Turkey in 2008?
Offer a very short reply. -5.04. What is the difference between the % of value added in manufacturing of Moldova in 2007 and the % of value added in manufacturing of Norway in 2008?
Ensure brevity in your answer.  24.38. What is the difference between the % of value added in manufacturing of Moldova in 2007 and the % of value added in manufacturing of Turkey in 2008?
Your answer should be compact. 26.23. What is the difference between the % of value added in manufacturing in Norway in 2007 and the % of value added in manufacturing in Turkey in 2008?
Keep it short and to the point. 2.11. What is the difference between the % of value added in manufacturing in Iran in 2007 and the % of value added in manufacturing in Moldova in 2009?
Keep it short and to the point. -33.29. What is the difference between the % of value added in manufacturing of Iran in 2007 and the % of value added in manufacturing of Norway in 2009?
Offer a terse response. -10.11. What is the difference between the % of value added in manufacturing of Iran in 2007 and the % of value added in manufacturing of Turkey in 2009?
Provide a short and direct response. -7.64. What is the difference between the % of value added in manufacturing in Moldova in 2007 and the % of value added in manufacturing in Norway in 2009?
Offer a very short reply. 21.15. What is the difference between the % of value added in manufacturing in Moldova in 2007 and the % of value added in manufacturing in Turkey in 2009?
Your answer should be very brief. 23.62. What is the difference between the % of value added in manufacturing of Norway in 2007 and the % of value added in manufacturing of Turkey in 2009?
Keep it short and to the point. -0.5. What is the difference between the % of value added in manufacturing of Iran in 2008 and the % of value added in manufacturing of Moldova in 2009?
Provide a succinct answer. -33.19. What is the difference between the % of value added in manufacturing of Iran in 2008 and the % of value added in manufacturing of Norway in 2009?
Your response must be concise. -10. What is the difference between the % of value added in manufacturing in Iran in 2008 and the % of value added in manufacturing in Turkey in 2009?
Offer a very short reply. -7.54. What is the difference between the % of value added in manufacturing in Moldova in 2008 and the % of value added in manufacturing in Norway in 2009?
Offer a terse response. 22.22. What is the difference between the % of value added in manufacturing in Moldova in 2008 and the % of value added in manufacturing in Turkey in 2009?
Your answer should be compact. 24.68. What is the difference between the % of value added in manufacturing in Norway in 2008 and the % of value added in manufacturing in Turkey in 2009?
Provide a short and direct response. -0.76. What is the average % of value added in manufacturing of Iran per year?
Provide a short and direct response. 9.05. What is the average % of value added in manufacturing in Moldova per year?
Your answer should be compact. 47.59. What is the average % of value added in manufacturing of Norway per year?
Your response must be concise. 16.75. What is the average % of value added in manufacturing of Turkey per year?
Make the answer very short. 13.98. In the year 2002, what is the difference between the % of value added in manufacturing of Iran and % of value added in manufacturing of Moldova?
Keep it short and to the point. -47.66. In the year 2002, what is the difference between the % of value added in manufacturing of Iran and % of value added in manufacturing of Norway?
Your response must be concise. -7.03. In the year 2002, what is the difference between the % of value added in manufacturing in Iran and % of value added in manufacturing in Turkey?
Give a very brief answer. -6.08. In the year 2002, what is the difference between the % of value added in manufacturing in Moldova and % of value added in manufacturing in Norway?
Give a very brief answer. 40.63. In the year 2002, what is the difference between the % of value added in manufacturing in Moldova and % of value added in manufacturing in Turkey?
Provide a succinct answer. 41.59. In the year 2002, what is the difference between the % of value added in manufacturing of Norway and % of value added in manufacturing of Turkey?
Give a very brief answer. 0.96. In the year 2003, what is the difference between the % of value added in manufacturing in Iran and % of value added in manufacturing in Moldova?
Your response must be concise. -47.28. In the year 2003, what is the difference between the % of value added in manufacturing in Iran and % of value added in manufacturing in Norway?
Your answer should be compact. -9.19. In the year 2003, what is the difference between the % of value added in manufacturing in Iran and % of value added in manufacturing in Turkey?
Ensure brevity in your answer.  -4.8. In the year 2003, what is the difference between the % of value added in manufacturing in Moldova and % of value added in manufacturing in Norway?
Provide a short and direct response. 38.09. In the year 2003, what is the difference between the % of value added in manufacturing in Moldova and % of value added in manufacturing in Turkey?
Give a very brief answer. 42.48. In the year 2003, what is the difference between the % of value added in manufacturing in Norway and % of value added in manufacturing in Turkey?
Offer a very short reply. 4.39. In the year 2004, what is the difference between the % of value added in manufacturing in Iran and % of value added in manufacturing in Moldova?
Make the answer very short. -43.93. In the year 2004, what is the difference between the % of value added in manufacturing of Iran and % of value added in manufacturing of Norway?
Provide a short and direct response. -8.61. In the year 2004, what is the difference between the % of value added in manufacturing of Iran and % of value added in manufacturing of Turkey?
Provide a succinct answer. -4.21. In the year 2004, what is the difference between the % of value added in manufacturing in Moldova and % of value added in manufacturing in Norway?
Provide a short and direct response. 35.31. In the year 2004, what is the difference between the % of value added in manufacturing of Moldova and % of value added in manufacturing of Turkey?
Your answer should be very brief. 39.72. In the year 2004, what is the difference between the % of value added in manufacturing of Norway and % of value added in manufacturing of Turkey?
Your answer should be compact. 4.4. In the year 2005, what is the difference between the % of value added in manufacturing in Iran and % of value added in manufacturing in Moldova?
Make the answer very short. -40.08. In the year 2005, what is the difference between the % of value added in manufacturing of Iran and % of value added in manufacturing of Norway?
Offer a terse response. -7.38. In the year 2005, what is the difference between the % of value added in manufacturing of Iran and % of value added in manufacturing of Turkey?
Ensure brevity in your answer.  -3.74. In the year 2005, what is the difference between the % of value added in manufacturing of Moldova and % of value added in manufacturing of Norway?
Your answer should be compact. 32.69. In the year 2005, what is the difference between the % of value added in manufacturing in Moldova and % of value added in manufacturing in Turkey?
Ensure brevity in your answer.  36.33. In the year 2005, what is the difference between the % of value added in manufacturing of Norway and % of value added in manufacturing of Turkey?
Make the answer very short. 3.64. In the year 2006, what is the difference between the % of value added in manufacturing in Iran and % of value added in manufacturing in Moldova?
Your response must be concise. -33.51. In the year 2006, what is the difference between the % of value added in manufacturing of Iran and % of value added in manufacturing of Norway?
Ensure brevity in your answer.  -6.22. In the year 2006, what is the difference between the % of value added in manufacturing in Iran and % of value added in manufacturing in Turkey?
Your response must be concise. -3.69. In the year 2006, what is the difference between the % of value added in manufacturing of Moldova and % of value added in manufacturing of Norway?
Ensure brevity in your answer.  27.29. In the year 2006, what is the difference between the % of value added in manufacturing in Moldova and % of value added in manufacturing in Turkey?
Provide a succinct answer. 29.82. In the year 2006, what is the difference between the % of value added in manufacturing of Norway and % of value added in manufacturing of Turkey?
Offer a terse response. 2.54. In the year 2007, what is the difference between the % of value added in manufacturing in Iran and % of value added in manufacturing in Moldova?
Your answer should be compact. -31.26. In the year 2007, what is the difference between the % of value added in manufacturing in Iran and % of value added in manufacturing in Norway?
Give a very brief answer. -7.15. In the year 2007, what is the difference between the % of value added in manufacturing of Iran and % of value added in manufacturing of Turkey?
Provide a short and direct response. -5.24. In the year 2007, what is the difference between the % of value added in manufacturing in Moldova and % of value added in manufacturing in Norway?
Your answer should be compact. 24.11. In the year 2007, what is the difference between the % of value added in manufacturing of Moldova and % of value added in manufacturing of Turkey?
Your response must be concise. 26.02. In the year 2007, what is the difference between the % of value added in manufacturing in Norway and % of value added in manufacturing in Turkey?
Make the answer very short. 1.91. In the year 2008, what is the difference between the % of value added in manufacturing of Iran and % of value added in manufacturing of Moldova?
Offer a terse response. -32.22. In the year 2008, what is the difference between the % of value added in manufacturing of Iran and % of value added in manufacturing of Norway?
Give a very brief answer. -6.77. In the year 2008, what is the difference between the % of value added in manufacturing of Iran and % of value added in manufacturing of Turkey?
Your response must be concise. -4.93. In the year 2008, what is the difference between the % of value added in manufacturing of Moldova and % of value added in manufacturing of Norway?
Offer a very short reply. 25.45. In the year 2008, what is the difference between the % of value added in manufacturing in Moldova and % of value added in manufacturing in Turkey?
Offer a terse response. 27.29. In the year 2008, what is the difference between the % of value added in manufacturing of Norway and % of value added in manufacturing of Turkey?
Give a very brief answer. 1.85. In the year 2009, what is the difference between the % of value added in manufacturing in Iran and % of value added in manufacturing in Moldova?
Ensure brevity in your answer.  -32.39. In the year 2009, what is the difference between the % of value added in manufacturing in Iran and % of value added in manufacturing in Norway?
Make the answer very short. -9.21. In the year 2009, what is the difference between the % of value added in manufacturing of Iran and % of value added in manufacturing of Turkey?
Provide a short and direct response. -6.74. In the year 2009, what is the difference between the % of value added in manufacturing in Moldova and % of value added in manufacturing in Norway?
Your response must be concise. 23.18. In the year 2009, what is the difference between the % of value added in manufacturing in Moldova and % of value added in manufacturing in Turkey?
Your response must be concise. 25.65. In the year 2009, what is the difference between the % of value added in manufacturing in Norway and % of value added in manufacturing in Turkey?
Your response must be concise. 2.46. What is the ratio of the % of value added in manufacturing in Iran in 2002 to that in 2003?
Provide a short and direct response. 1.15. What is the ratio of the % of value added in manufacturing of Moldova in 2002 to that in 2003?
Provide a succinct answer. 1.03. What is the ratio of the % of value added in manufacturing of Norway in 2002 to that in 2003?
Offer a very short reply. 0.96. What is the ratio of the % of value added in manufacturing of Turkey in 2002 to that in 2003?
Give a very brief answer. 1.19. What is the ratio of the % of value added in manufacturing in Iran in 2002 to that in 2004?
Offer a terse response. 1.28. What is the ratio of the % of value added in manufacturing in Moldova in 2002 to that in 2004?
Offer a very short reply. 1.12. What is the ratio of the % of value added in manufacturing in Norway in 2002 to that in 2004?
Ensure brevity in your answer.  1.05. What is the ratio of the % of value added in manufacturing of Turkey in 2002 to that in 2004?
Provide a short and direct response. 1.34. What is the ratio of the % of value added in manufacturing of Iran in 2002 to that in 2005?
Offer a very short reply. 1.15. What is the ratio of the % of value added in manufacturing in Moldova in 2002 to that in 2005?
Your answer should be compact. 1.18. What is the ratio of the % of value added in manufacturing in Norway in 2002 to that in 2005?
Provide a short and direct response. 1.07. What is the ratio of the % of value added in manufacturing in Turkey in 2002 to that in 2005?
Offer a terse response. 1.28. What is the ratio of the % of value added in manufacturing in Iran in 2002 to that in 2006?
Provide a short and direct response. 1.28. What is the ratio of the % of value added in manufacturing of Moldova in 2002 to that in 2006?
Offer a very short reply. 1.39. What is the ratio of the % of value added in manufacturing of Norway in 2002 to that in 2006?
Offer a very short reply. 1.22. What is the ratio of the % of value added in manufacturing of Turkey in 2002 to that in 2006?
Give a very brief answer. 1.39. What is the ratio of the % of value added in manufacturing of Iran in 2002 to that in 2007?
Keep it short and to the point. 1.44. What is the ratio of the % of value added in manufacturing of Moldova in 2002 to that in 2007?
Make the answer very short. 1.51. What is the ratio of the % of value added in manufacturing in Norway in 2002 to that in 2007?
Keep it short and to the point. 1.22. What is the ratio of the % of value added in manufacturing in Turkey in 2002 to that in 2007?
Give a very brief answer. 1.33. What is the ratio of the % of value added in manufacturing of Iran in 2002 to that in 2008?
Ensure brevity in your answer.  1.42. What is the ratio of the % of value added in manufacturing in Moldova in 2002 to that in 2008?
Ensure brevity in your answer.  1.47. What is the ratio of the % of value added in manufacturing of Norway in 2002 to that in 2008?
Your answer should be very brief. 1.24. What is the ratio of the % of value added in manufacturing in Turkey in 2002 to that in 2008?
Make the answer very short. 1.35. What is the ratio of the % of value added in manufacturing in Iran in 2002 to that in 2009?
Offer a terse response. 1.29. What is the ratio of the % of value added in manufacturing of Moldova in 2002 to that in 2009?
Provide a succinct answer. 1.43. What is the ratio of the % of value added in manufacturing of Norway in 2002 to that in 2009?
Ensure brevity in your answer.  1.02. What is the ratio of the % of value added in manufacturing of Turkey in 2002 to that in 2009?
Give a very brief answer. 1.12. What is the ratio of the % of value added in manufacturing in Iran in 2003 to that in 2004?
Provide a succinct answer. 1.11. What is the ratio of the % of value added in manufacturing of Moldova in 2003 to that in 2004?
Make the answer very short. 1.08. What is the ratio of the % of value added in manufacturing of Norway in 2003 to that in 2004?
Ensure brevity in your answer.  1.09. What is the ratio of the % of value added in manufacturing in Turkey in 2003 to that in 2004?
Provide a succinct answer. 1.12. What is the ratio of the % of value added in manufacturing of Moldova in 2003 to that in 2005?
Provide a short and direct response. 1.15. What is the ratio of the % of value added in manufacturing in Norway in 2003 to that in 2005?
Ensure brevity in your answer.  1.11. What is the ratio of the % of value added in manufacturing of Turkey in 2003 to that in 2005?
Provide a succinct answer. 1.08. What is the ratio of the % of value added in manufacturing in Iran in 2003 to that in 2006?
Your response must be concise. 1.12. What is the ratio of the % of value added in manufacturing in Moldova in 2003 to that in 2006?
Your answer should be very brief. 1.35. What is the ratio of the % of value added in manufacturing in Norway in 2003 to that in 2006?
Offer a very short reply. 1.27. What is the ratio of the % of value added in manufacturing of Turkey in 2003 to that in 2006?
Offer a terse response. 1.17. What is the ratio of the % of value added in manufacturing in Iran in 2003 to that in 2007?
Offer a very short reply. 1.25. What is the ratio of the % of value added in manufacturing of Moldova in 2003 to that in 2007?
Provide a short and direct response. 1.46. What is the ratio of the % of value added in manufacturing in Norway in 2003 to that in 2007?
Give a very brief answer. 1.27. What is the ratio of the % of value added in manufacturing of Turkey in 2003 to that in 2007?
Your answer should be very brief. 1.12. What is the ratio of the % of value added in manufacturing of Iran in 2003 to that in 2008?
Provide a succinct answer. 1.23. What is the ratio of the % of value added in manufacturing in Moldova in 2003 to that in 2008?
Make the answer very short. 1.42. What is the ratio of the % of value added in manufacturing of Norway in 2003 to that in 2008?
Offer a terse response. 1.29. What is the ratio of the % of value added in manufacturing of Turkey in 2003 to that in 2008?
Your response must be concise. 1.13. What is the ratio of the % of value added in manufacturing in Iran in 2003 to that in 2009?
Ensure brevity in your answer.  1.12. What is the ratio of the % of value added in manufacturing of Moldova in 2003 to that in 2009?
Give a very brief answer. 1.39. What is the ratio of the % of value added in manufacturing in Norway in 2003 to that in 2009?
Make the answer very short. 1.06. What is the ratio of the % of value added in manufacturing of Turkey in 2003 to that in 2009?
Make the answer very short. 0.94. What is the ratio of the % of value added in manufacturing in Iran in 2004 to that in 2005?
Make the answer very short. 0.9. What is the ratio of the % of value added in manufacturing in Moldova in 2004 to that in 2005?
Provide a short and direct response. 1.06. What is the ratio of the % of value added in manufacturing in Norway in 2004 to that in 2005?
Provide a short and direct response. 1.01. What is the ratio of the % of value added in manufacturing of Turkey in 2004 to that in 2005?
Provide a short and direct response. 0.96. What is the ratio of the % of value added in manufacturing in Iran in 2004 to that in 2006?
Offer a terse response. 1. What is the ratio of the % of value added in manufacturing of Moldova in 2004 to that in 2006?
Ensure brevity in your answer.  1.25. What is the ratio of the % of value added in manufacturing of Norway in 2004 to that in 2006?
Offer a very short reply. 1.16. What is the ratio of the % of value added in manufacturing of Turkey in 2004 to that in 2006?
Offer a very short reply. 1.04. What is the ratio of the % of value added in manufacturing in Iran in 2004 to that in 2007?
Offer a very short reply. 1.12. What is the ratio of the % of value added in manufacturing of Moldova in 2004 to that in 2007?
Provide a succinct answer. 1.35. What is the ratio of the % of value added in manufacturing in Norway in 2004 to that in 2007?
Give a very brief answer. 1.16. What is the ratio of the % of value added in manufacturing in Turkey in 2004 to that in 2007?
Keep it short and to the point. 0.99. What is the ratio of the % of value added in manufacturing in Iran in 2004 to that in 2008?
Make the answer very short. 1.11. What is the ratio of the % of value added in manufacturing in Moldova in 2004 to that in 2008?
Your answer should be compact. 1.31. What is the ratio of the % of value added in manufacturing in Norway in 2004 to that in 2008?
Ensure brevity in your answer.  1.18. What is the ratio of the % of value added in manufacturing in Iran in 2004 to that in 2009?
Make the answer very short. 1. What is the ratio of the % of value added in manufacturing in Moldova in 2004 to that in 2009?
Your response must be concise. 1.28. What is the ratio of the % of value added in manufacturing of Turkey in 2004 to that in 2009?
Ensure brevity in your answer.  0.84. What is the ratio of the % of value added in manufacturing of Iran in 2005 to that in 2006?
Your response must be concise. 1.11. What is the ratio of the % of value added in manufacturing of Moldova in 2005 to that in 2006?
Give a very brief answer. 1.18. What is the ratio of the % of value added in manufacturing in Norway in 2005 to that in 2006?
Your answer should be very brief. 1.14. What is the ratio of the % of value added in manufacturing of Turkey in 2005 to that in 2006?
Ensure brevity in your answer.  1.08. What is the ratio of the % of value added in manufacturing of Iran in 2005 to that in 2007?
Give a very brief answer. 1.25. What is the ratio of the % of value added in manufacturing of Moldova in 2005 to that in 2007?
Give a very brief answer. 1.27. What is the ratio of the % of value added in manufacturing of Norway in 2005 to that in 2007?
Make the answer very short. 1.14. What is the ratio of the % of value added in manufacturing of Turkey in 2005 to that in 2007?
Make the answer very short. 1.03. What is the ratio of the % of value added in manufacturing in Iran in 2005 to that in 2008?
Your answer should be compact. 1.23. What is the ratio of the % of value added in manufacturing of Moldova in 2005 to that in 2008?
Ensure brevity in your answer.  1.24. What is the ratio of the % of value added in manufacturing of Norway in 2005 to that in 2008?
Keep it short and to the point. 1.17. What is the ratio of the % of value added in manufacturing in Turkey in 2005 to that in 2008?
Keep it short and to the point. 1.05. What is the ratio of the % of value added in manufacturing of Iran in 2005 to that in 2009?
Ensure brevity in your answer.  1.12. What is the ratio of the % of value added in manufacturing in Moldova in 2005 to that in 2009?
Provide a succinct answer. 1.21. What is the ratio of the % of value added in manufacturing of Norway in 2005 to that in 2009?
Ensure brevity in your answer.  0.95. What is the ratio of the % of value added in manufacturing in Turkey in 2005 to that in 2009?
Provide a short and direct response. 0.87. What is the ratio of the % of value added in manufacturing of Iran in 2006 to that in 2007?
Make the answer very short. 1.12. What is the ratio of the % of value added in manufacturing of Moldova in 2006 to that in 2007?
Your answer should be very brief. 1.08. What is the ratio of the % of value added in manufacturing of Norway in 2006 to that in 2007?
Ensure brevity in your answer.  1. What is the ratio of the % of value added in manufacturing of Turkey in 2006 to that in 2007?
Provide a short and direct response. 0.95. What is the ratio of the % of value added in manufacturing of Iran in 2006 to that in 2008?
Your answer should be compact. 1.1. What is the ratio of the % of value added in manufacturing in Moldova in 2006 to that in 2008?
Your answer should be very brief. 1.05. What is the ratio of the % of value added in manufacturing of Norway in 2006 to that in 2008?
Your response must be concise. 1.02. What is the ratio of the % of value added in manufacturing in Turkey in 2006 to that in 2008?
Give a very brief answer. 0.97. What is the ratio of the % of value added in manufacturing in Iran in 2006 to that in 2009?
Provide a short and direct response. 1. What is the ratio of the % of value added in manufacturing in Moldova in 2006 to that in 2009?
Your answer should be compact. 1.03. What is the ratio of the % of value added in manufacturing of Norway in 2006 to that in 2009?
Keep it short and to the point. 0.83. What is the ratio of the % of value added in manufacturing in Turkey in 2006 to that in 2009?
Your answer should be compact. 0.8. What is the ratio of the % of value added in manufacturing of Iran in 2007 to that in 2008?
Your response must be concise. 0.99. What is the ratio of the % of value added in manufacturing in Moldova in 2007 to that in 2008?
Offer a terse response. 0.97. What is the ratio of the % of value added in manufacturing of Norway in 2007 to that in 2008?
Your answer should be very brief. 1.02. What is the ratio of the % of value added in manufacturing in Iran in 2007 to that in 2009?
Offer a terse response. 0.9. What is the ratio of the % of value added in manufacturing of Moldova in 2007 to that in 2009?
Offer a terse response. 0.95. What is the ratio of the % of value added in manufacturing in Norway in 2007 to that in 2009?
Your answer should be very brief. 0.83. What is the ratio of the % of value added in manufacturing of Turkey in 2007 to that in 2009?
Offer a very short reply. 0.84. What is the ratio of the % of value added in manufacturing in Iran in 2008 to that in 2009?
Your answer should be compact. 0.91. What is the ratio of the % of value added in manufacturing in Moldova in 2008 to that in 2009?
Offer a terse response. 0.98. What is the ratio of the % of value added in manufacturing of Norway in 2008 to that in 2009?
Your response must be concise. 0.82. What is the ratio of the % of value added in manufacturing of Turkey in 2008 to that in 2009?
Provide a short and direct response. 0.83. What is the difference between the highest and the second highest % of value added in manufacturing of Iran?
Offer a very short reply. 1.47. What is the difference between the highest and the second highest % of value added in manufacturing in Moldova?
Offer a terse response. 1.86. What is the difference between the highest and the second highest % of value added in manufacturing in Norway?
Your answer should be very brief. 0.69. What is the difference between the highest and the second highest % of value added in manufacturing in Turkey?
Ensure brevity in your answer.  1.84. What is the difference between the highest and the lowest % of value added in manufacturing in Iran?
Give a very brief answer. 3.41. What is the difference between the highest and the lowest % of value added in manufacturing of Moldova?
Ensure brevity in your answer.  19.82. What is the difference between the highest and the lowest % of value added in manufacturing of Norway?
Provide a short and direct response. 4.25. What is the difference between the highest and the lowest % of value added in manufacturing of Turkey?
Keep it short and to the point. 4.87. 